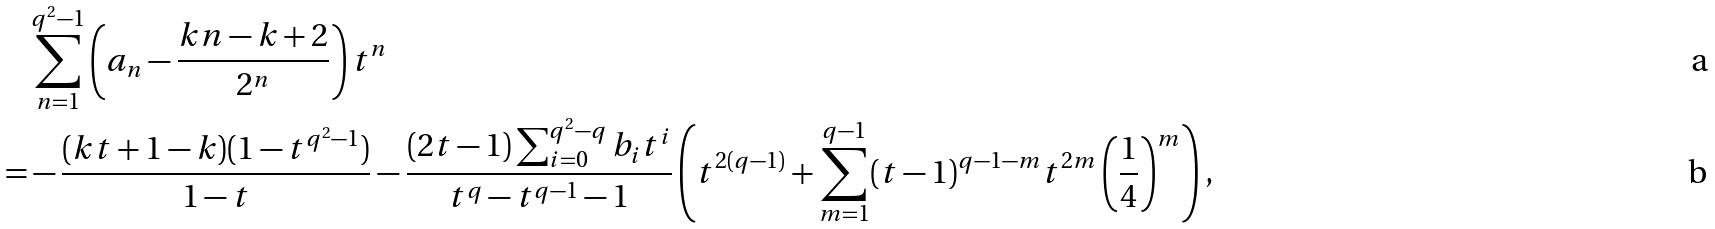Convert formula to latex. <formula><loc_0><loc_0><loc_500><loc_500>& \sum _ { n = 1 } ^ { q ^ { 2 } - 1 } \left ( a _ { n } - \frac { k n - k + 2 } { 2 ^ { n } } \right ) t ^ { n } \\ = & - \frac { ( k t + 1 - k ) ( 1 - t ^ { q ^ { 2 } - 1 } ) } { 1 - t } - \frac { ( 2 t - 1 ) \sum _ { i = 0 } ^ { q ^ { 2 } - q } b _ { i } t ^ { i } } { t ^ { q } - t ^ { q - 1 } - 1 } \left ( t ^ { 2 ( q - 1 ) } + \sum _ { m = 1 } ^ { q - 1 } ( t - 1 ) ^ { q - 1 - m } t ^ { 2 m } \left ( \frac { 1 } { 4 } \right ) ^ { m } \right ) ,</formula> 